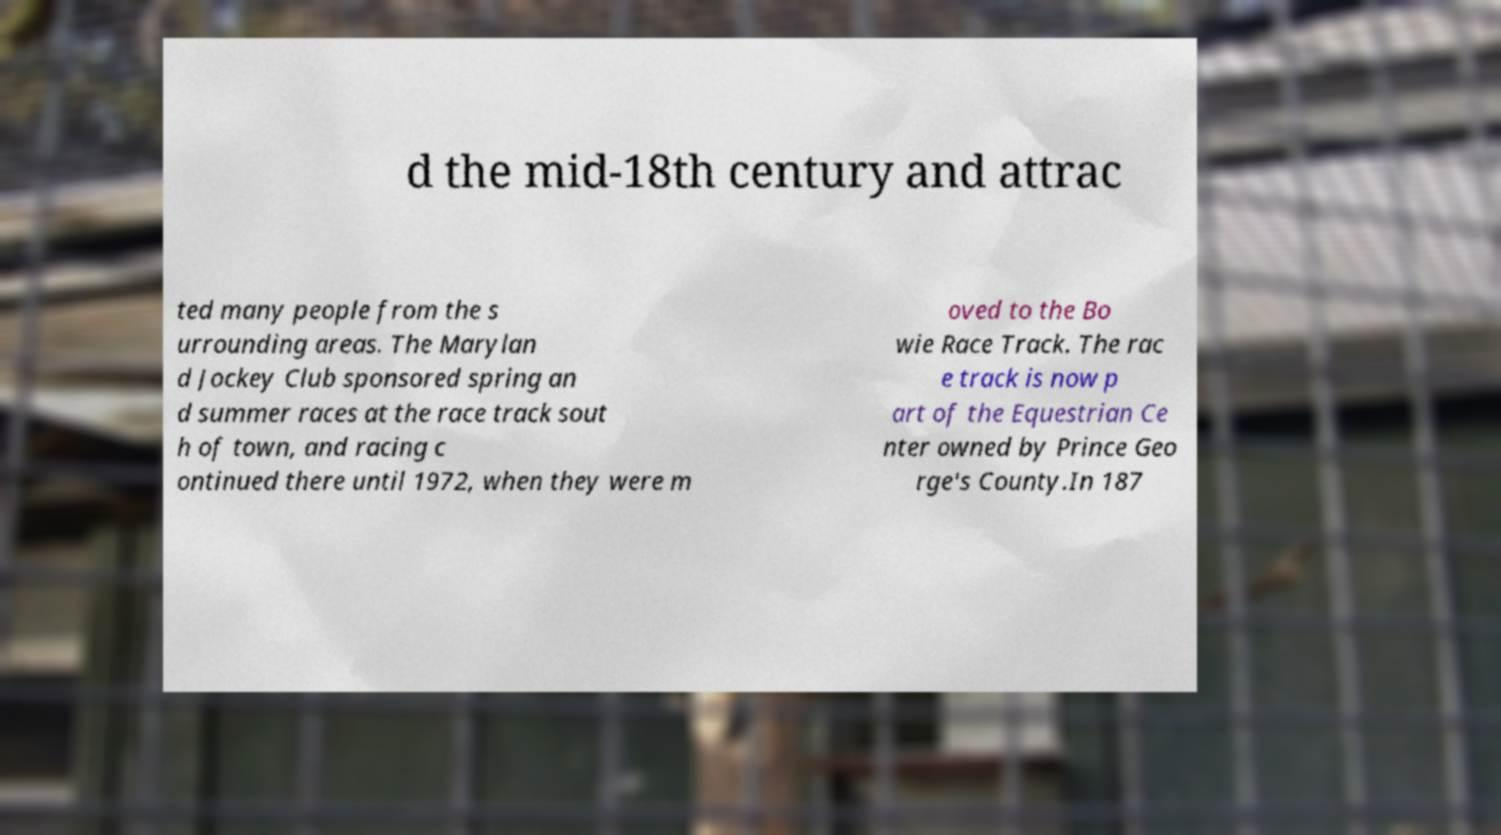Please identify and transcribe the text found in this image. d the mid-18th century and attrac ted many people from the s urrounding areas. The Marylan d Jockey Club sponsored spring an d summer races at the race track sout h of town, and racing c ontinued there until 1972, when they were m oved to the Bo wie Race Track. The rac e track is now p art of the Equestrian Ce nter owned by Prince Geo rge's County.In 187 